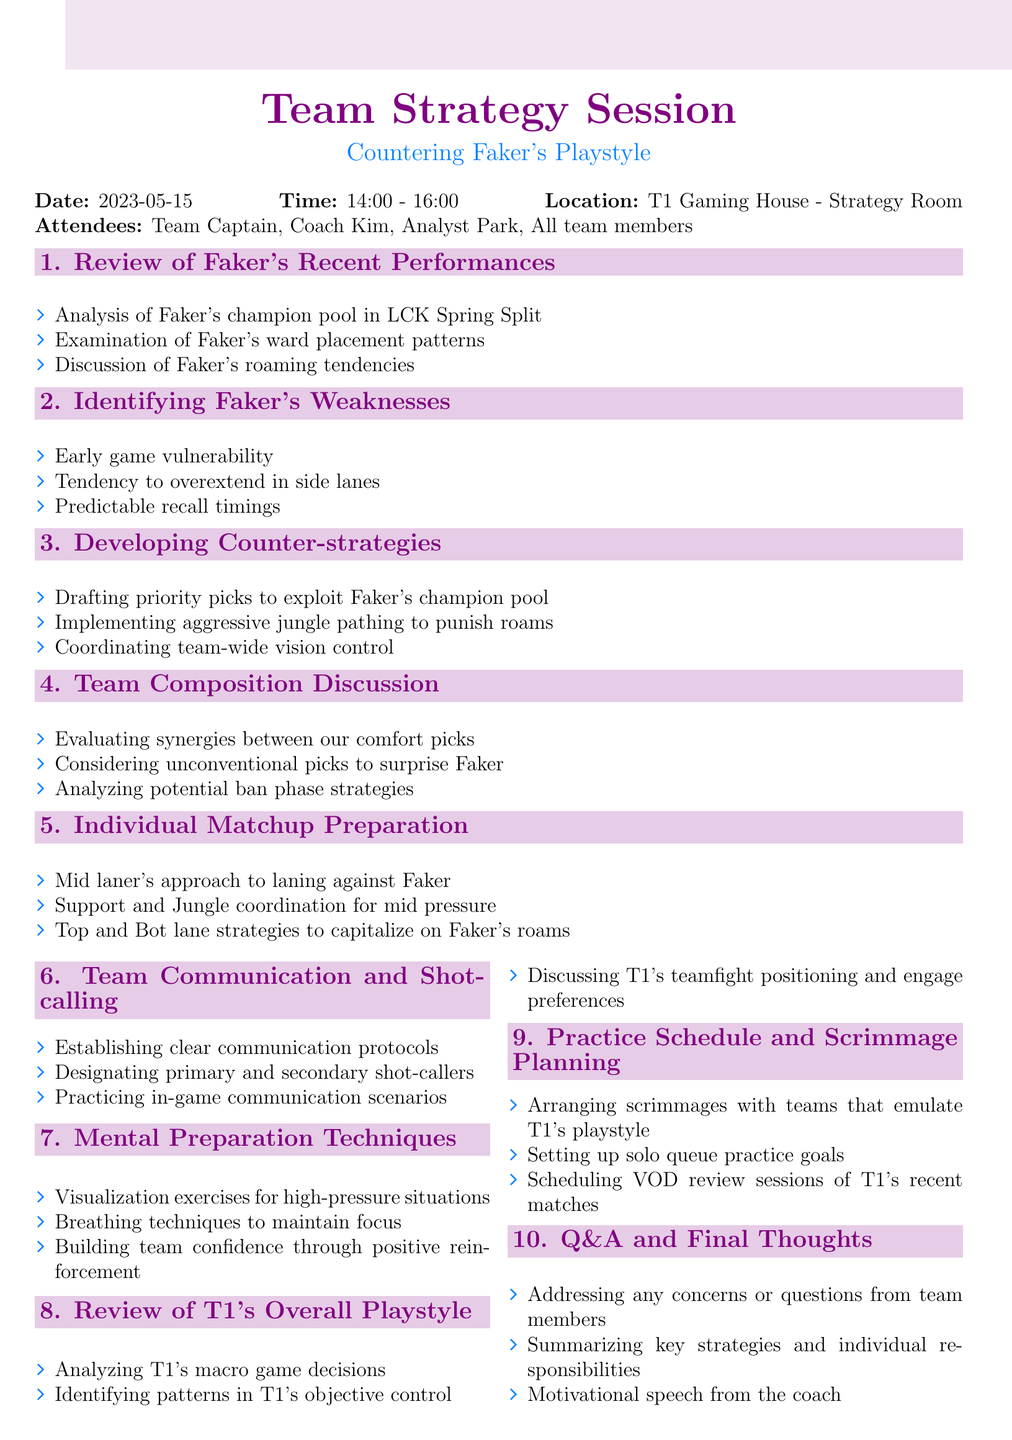What is the date of the meeting? The date of the meeting is specified in the document as May 15, 2023.
Answer: 2023-05-15 Who is one of the main attendees listed? The document lists the attendees, including the Team Captain, as part of the attendees.
Answer: Team Captain What is the duration of the meeting? The duration is calculated from the start time of 14:00 and the end time of 16:00, which is two hours.
Answer: 2 hours What is the main topic of the session? The title of the meeting reveals that it focuses on countering Faker's playstyle.
Answer: Countering Faker's Playstyle How many agenda items are listed in the document? The document outlines a total of ten distinct agenda items for discussion.
Answer: 10 Which section discusses Faker's early game weaknesses? The section specifically titled "Identifying Faker's Weaknesses" examines his early game vulnerability.
Answer: Identifying Faker's Weaknesses In which section is team communication addressed? Team communication is specifically covered under the section titled "Team Communication and Shot-calling."
Answer: Team Communication and Shot-calling What preparation techniques are mentioned for mental readiness? The section "Mental Preparation Techniques" discusses visualization exercises among other techniques.
Answer: Visualization exercises Which item on the agenda relates to practice scheduling? The section titled "Practice Schedule and Scrimmage Planning" focuses on organizing practice sessions.
Answer: Practice Schedule and Scrimmage Planning What is the last agenda item of the meeting? The final item on the agenda is labeled "Q&A and Final Thoughts," which typically wraps up the session.
Answer: Q&A and Final Thoughts 